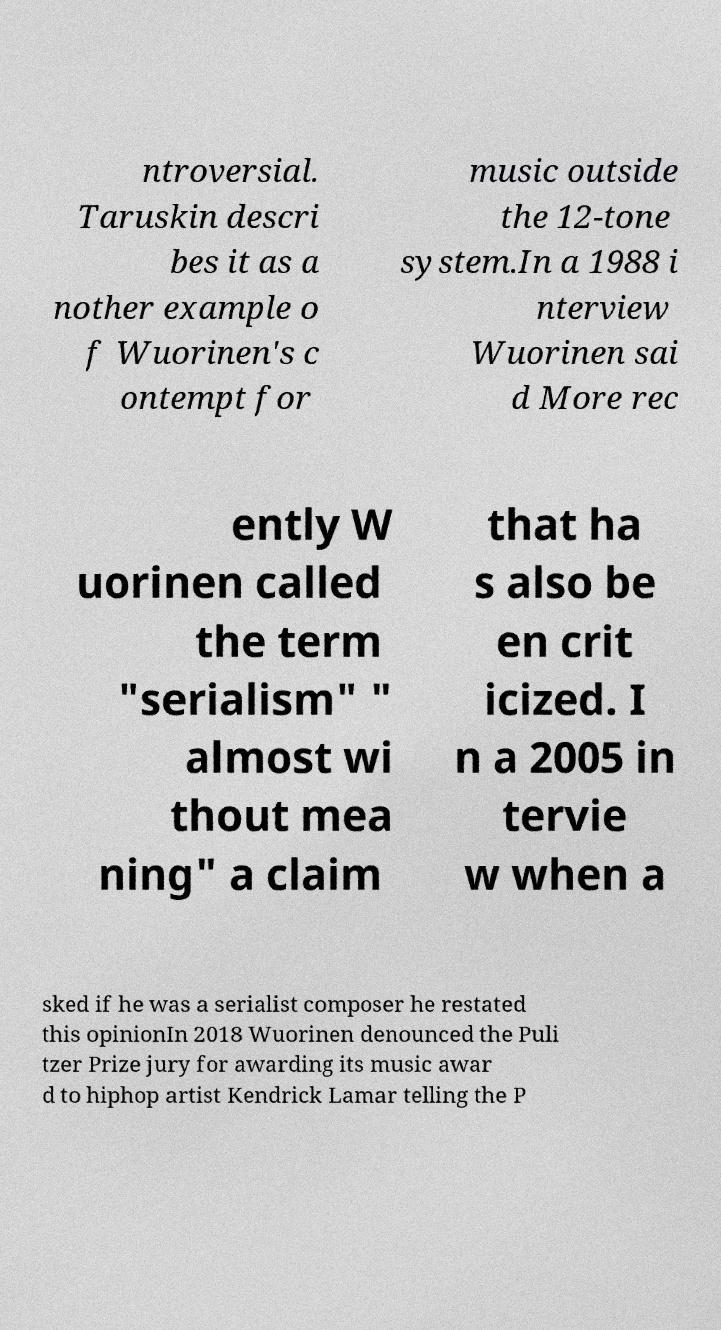Please identify and transcribe the text found in this image. ntroversial. Taruskin descri bes it as a nother example o f Wuorinen's c ontempt for music outside the 12-tone system.In a 1988 i nterview Wuorinen sai d More rec ently W uorinen called the term "serialism" " almost wi thout mea ning" a claim that ha s also be en crit icized. I n a 2005 in tervie w when a sked if he was a serialist composer he restated this opinionIn 2018 Wuorinen denounced the Puli tzer Prize jury for awarding its music awar d to hiphop artist Kendrick Lamar telling the P 